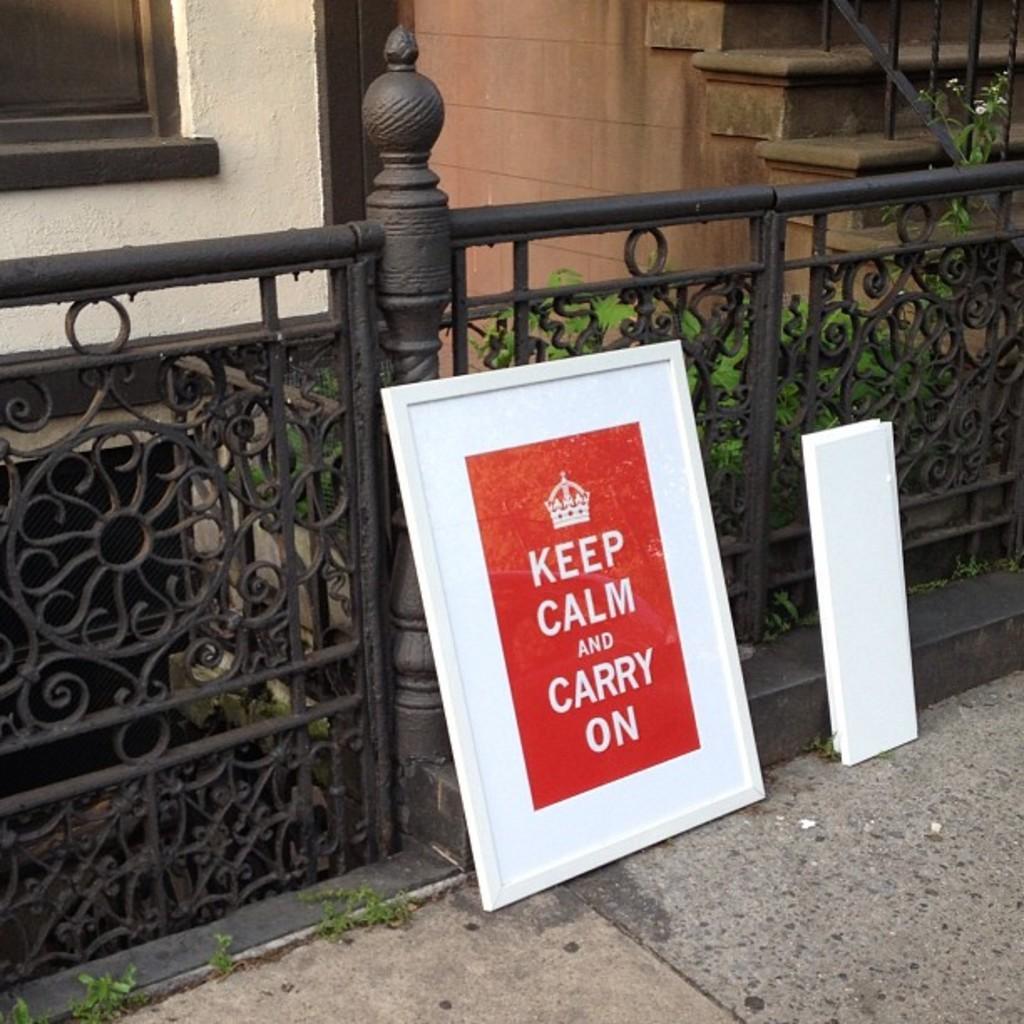Can you describe this image briefly? In this picture there is a red and white color photo frame at the metal grill pipe. Behind there are steps and yellow color wall. 